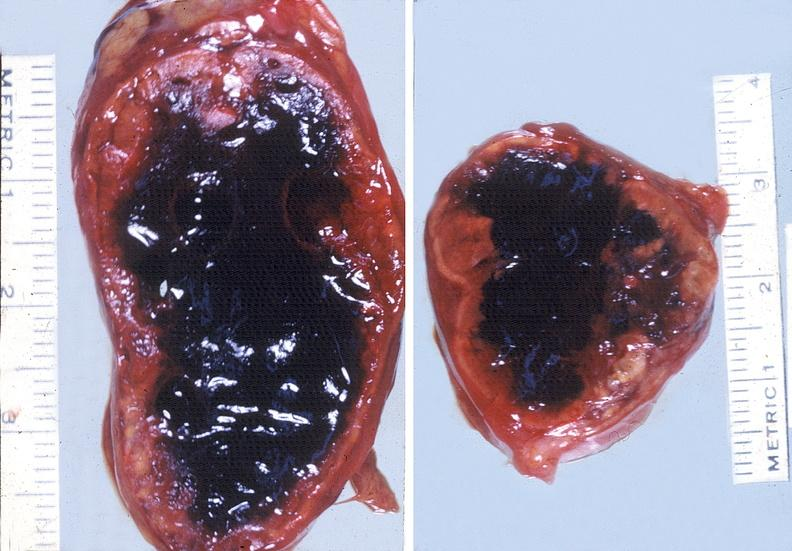s endocrine present?
Answer the question using a single word or phrase. Yes 